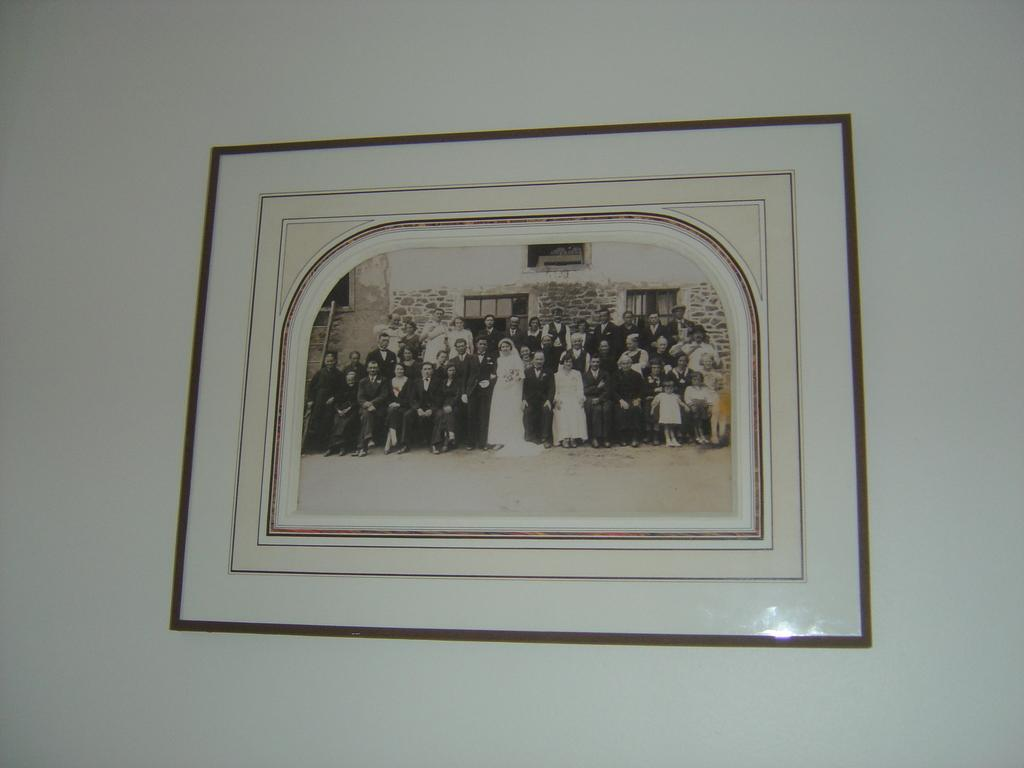What is hanging on the wall in the image? There is a photo frame on the wall in the image. What is inside the photo frame? The photo frame contains a picture of a group of people. What type of butter is being used to fix the error in the arithmetic problem in the image? There is no butter, error, or arithmetic problem present in the image. 